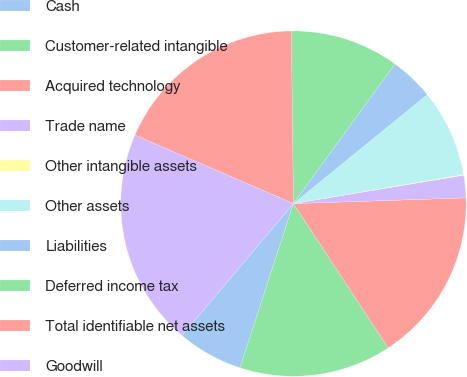<chart> <loc_0><loc_0><loc_500><loc_500><pie_chart><fcel>Cash<fcel>Customer-related intangible<fcel>Acquired technology<fcel>Trade name<fcel>Other intangible assets<fcel>Other assets<fcel>Liabilities<fcel>Deferred income tax<fcel>Total identifiable net assets<fcel>Goodwill<nl><fcel>6.15%<fcel>14.26%<fcel>16.28%<fcel>2.1%<fcel>0.07%<fcel>8.18%<fcel>4.12%<fcel>10.2%<fcel>18.31%<fcel>20.34%<nl></chart> 